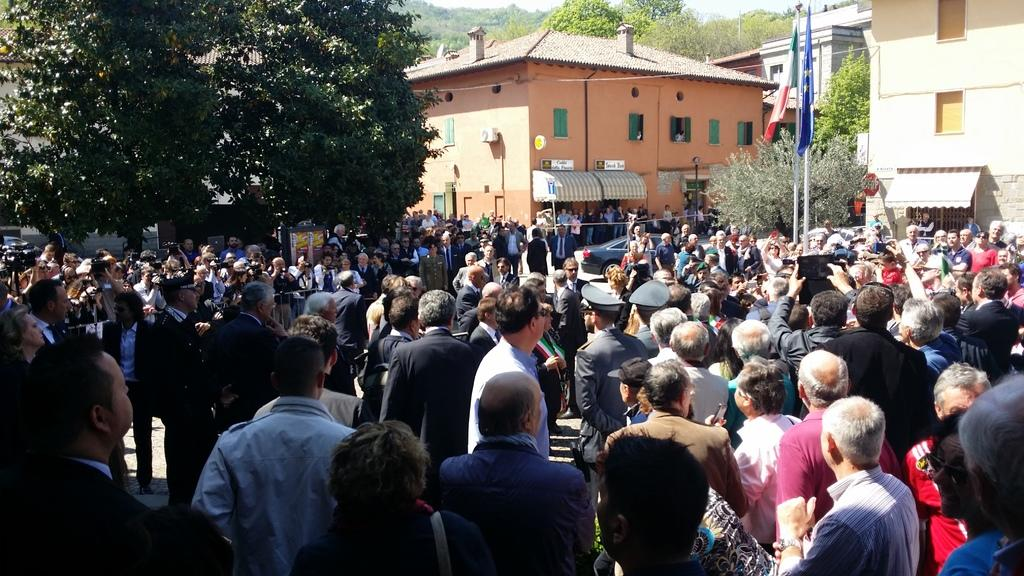What is happening on the land in the image? There are many people standing on the land in the image. What can be seen in the background of the image? There are buildings in the background of the image. What type of vegetation is present in the image? Trees are present all over the place in the image. Where are the flags located in the image? The flags are on the right side of the image. What type of flame can be seen on the trees in the image? There are no flames present in the image; it features people, buildings, trees, and flags. What type of drug is being used by the people in the image? There is no indication in the image that the people are using any drugs, so it cannot be determined from the picture. 